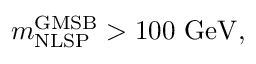Convert formula to latex. <formula><loc_0><loc_0><loc_500><loc_500>m _ { N L S P } ^ { G M S B } > 1 0 0 G e V ,</formula> 